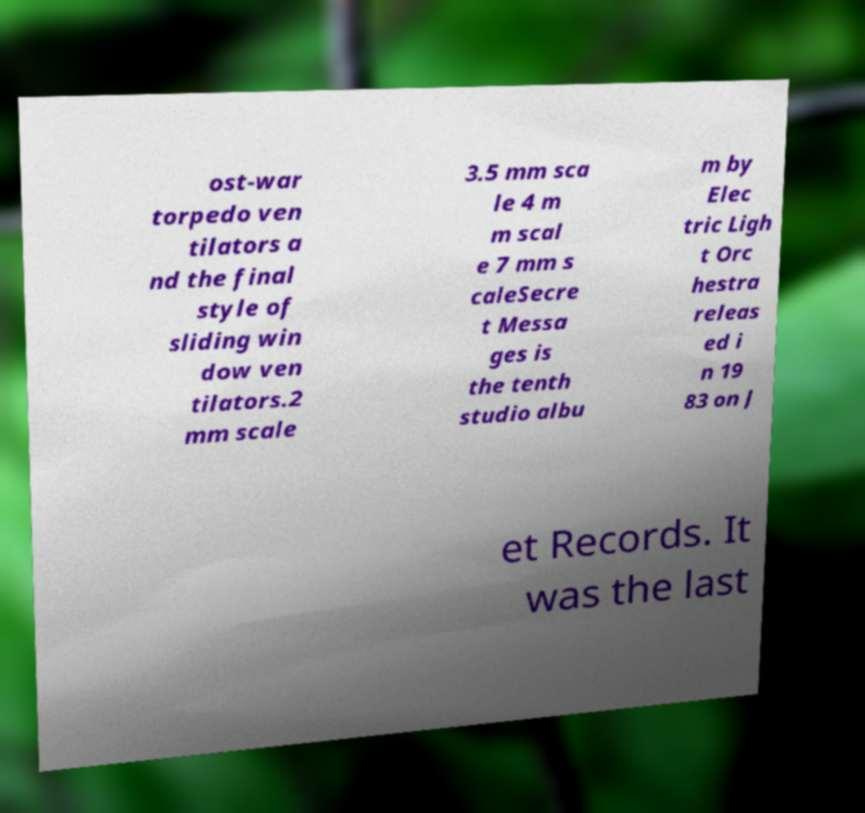Can you accurately transcribe the text from the provided image for me? ost-war torpedo ven tilators a nd the final style of sliding win dow ven tilators.2 mm scale 3.5 mm sca le 4 m m scal e 7 mm s caleSecre t Messa ges is the tenth studio albu m by Elec tric Ligh t Orc hestra releas ed i n 19 83 on J et Records. It was the last 